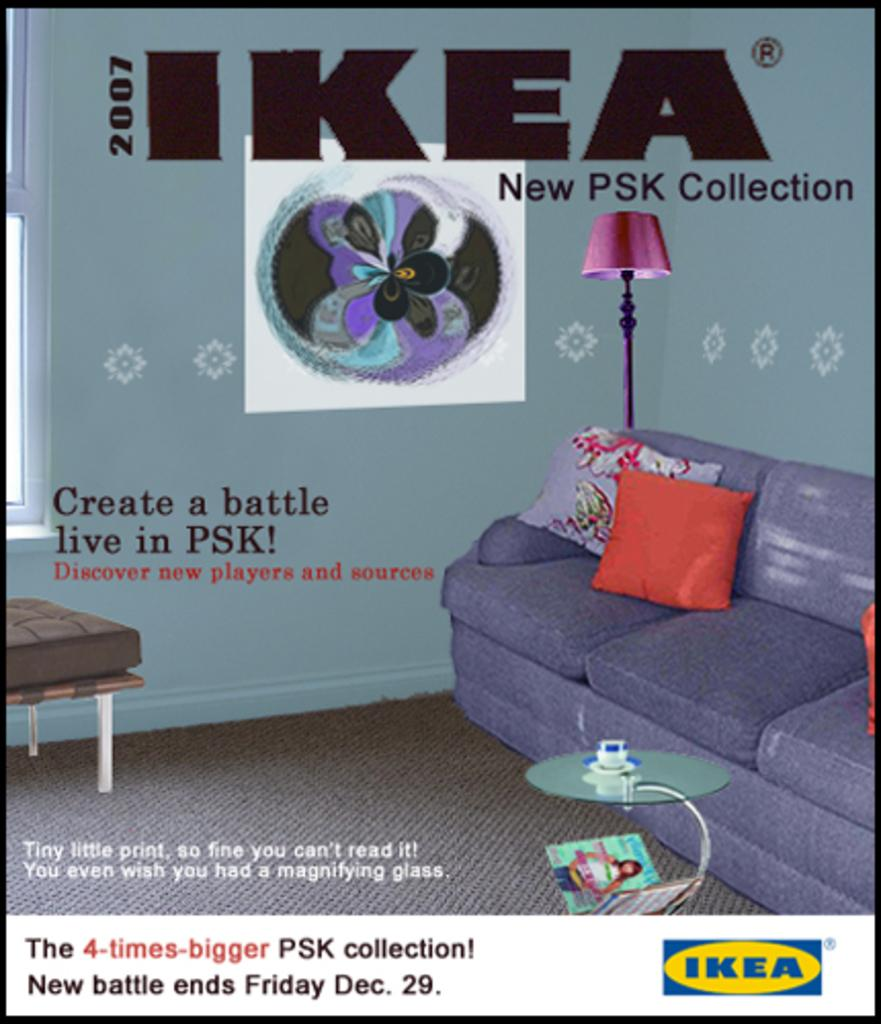What type of furniture is in the image? There is a sofa in the image. What is placed on the sofa? There is a pillow on the sofa. What is the source of light in the image? There is a lamp in the image. What can be seen beneath the furniture and objects in the image? The floor is visible in the image. What type of calculator is on the sofa in the image? There is no calculator present in the image. Can you tell me what book is being read on the sofa in the image? There is no book visible in the image. 